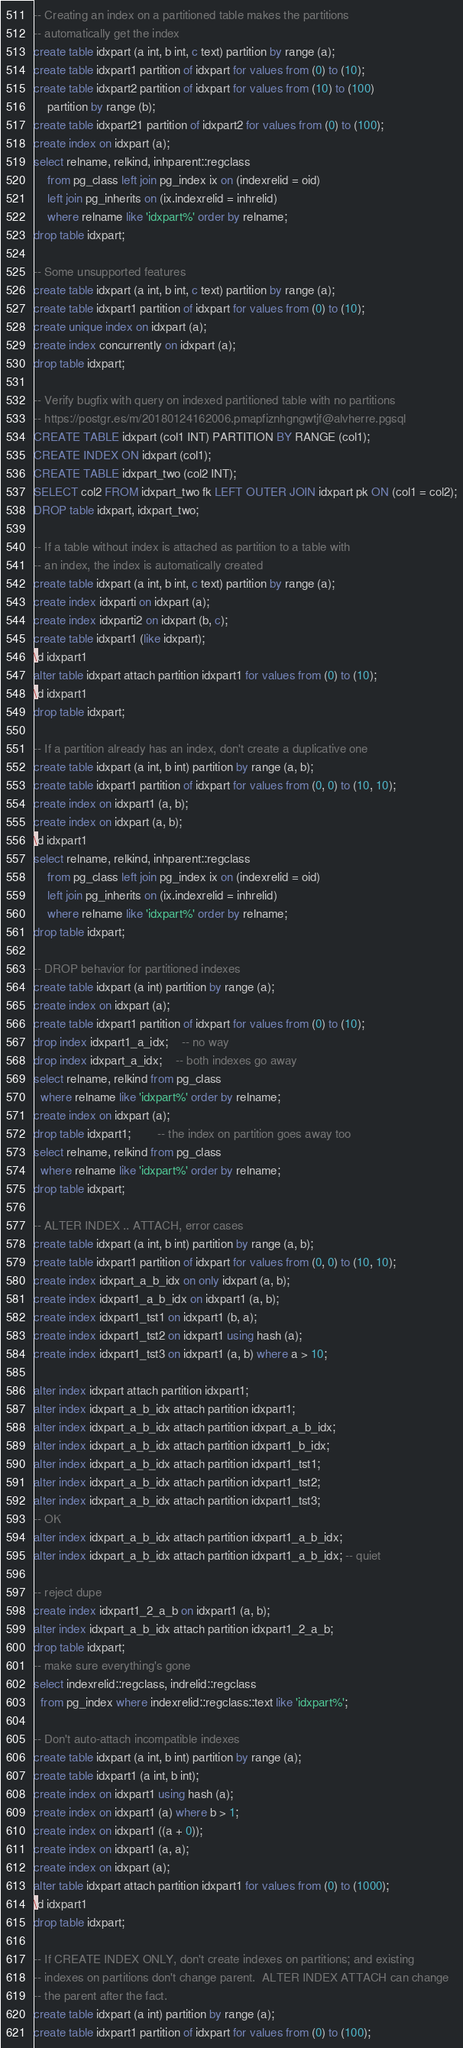Convert code to text. <code><loc_0><loc_0><loc_500><loc_500><_SQL_>-- Creating an index on a partitioned table makes the partitions
-- automatically get the index
create table idxpart (a int, b int, c text) partition by range (a);
create table idxpart1 partition of idxpart for values from (0) to (10);
create table idxpart2 partition of idxpart for values from (10) to (100)
	partition by range (b);
create table idxpart21 partition of idxpart2 for values from (0) to (100);
create index on idxpart (a);
select relname, relkind, inhparent::regclass
    from pg_class left join pg_index ix on (indexrelid = oid)
	left join pg_inherits on (ix.indexrelid = inhrelid)
	where relname like 'idxpart%' order by relname;
drop table idxpart;

-- Some unsupported features
create table idxpart (a int, b int, c text) partition by range (a);
create table idxpart1 partition of idxpart for values from (0) to (10);
create unique index on idxpart (a);
create index concurrently on idxpart (a);
drop table idxpart;

-- Verify bugfix with query on indexed partitioned table with no partitions
-- https://postgr.es/m/20180124162006.pmapfiznhgngwtjf@alvherre.pgsql
CREATE TABLE idxpart (col1 INT) PARTITION BY RANGE (col1);
CREATE INDEX ON idxpart (col1);
CREATE TABLE idxpart_two (col2 INT);
SELECT col2 FROM idxpart_two fk LEFT OUTER JOIN idxpart pk ON (col1 = col2);
DROP table idxpart, idxpart_two;

-- If a table without index is attached as partition to a table with
-- an index, the index is automatically created
create table idxpart (a int, b int, c text) partition by range (a);
create index idxparti on idxpart (a);
create index idxparti2 on idxpart (b, c);
create table idxpart1 (like idxpart);
\d idxpart1
alter table idxpart attach partition idxpart1 for values from (0) to (10);
\d idxpart1
drop table idxpart;

-- If a partition already has an index, don't create a duplicative one
create table idxpart (a int, b int) partition by range (a, b);
create table idxpart1 partition of idxpart for values from (0, 0) to (10, 10);
create index on idxpart1 (a, b);
create index on idxpart (a, b);
\d idxpart1
select relname, relkind, inhparent::regclass
    from pg_class left join pg_index ix on (indexrelid = oid)
	left join pg_inherits on (ix.indexrelid = inhrelid)
	where relname like 'idxpart%' order by relname;
drop table idxpart;

-- DROP behavior for partitioned indexes
create table idxpart (a int) partition by range (a);
create index on idxpart (a);
create table idxpart1 partition of idxpart for values from (0) to (10);
drop index idxpart1_a_idx;	-- no way
drop index idxpart_a_idx;	-- both indexes go away
select relname, relkind from pg_class
  where relname like 'idxpart%' order by relname;
create index on idxpart (a);
drop table idxpart1;		-- the index on partition goes away too
select relname, relkind from pg_class
  where relname like 'idxpart%' order by relname;
drop table idxpart;

-- ALTER INDEX .. ATTACH, error cases
create table idxpart (a int, b int) partition by range (a, b);
create table idxpart1 partition of idxpart for values from (0, 0) to (10, 10);
create index idxpart_a_b_idx on only idxpart (a, b);
create index idxpart1_a_b_idx on idxpart1 (a, b);
create index idxpart1_tst1 on idxpart1 (b, a);
create index idxpart1_tst2 on idxpart1 using hash (a);
create index idxpart1_tst3 on idxpart1 (a, b) where a > 10;

alter index idxpart attach partition idxpart1;
alter index idxpart_a_b_idx attach partition idxpart1;
alter index idxpart_a_b_idx attach partition idxpart_a_b_idx;
alter index idxpart_a_b_idx attach partition idxpart1_b_idx;
alter index idxpart_a_b_idx attach partition idxpart1_tst1;
alter index idxpart_a_b_idx attach partition idxpart1_tst2;
alter index idxpart_a_b_idx attach partition idxpart1_tst3;
-- OK
alter index idxpart_a_b_idx attach partition idxpart1_a_b_idx;
alter index idxpart_a_b_idx attach partition idxpart1_a_b_idx; -- quiet

-- reject dupe
create index idxpart1_2_a_b on idxpart1 (a, b);
alter index idxpart_a_b_idx attach partition idxpart1_2_a_b;
drop table idxpart;
-- make sure everything's gone
select indexrelid::regclass, indrelid::regclass
  from pg_index where indexrelid::regclass::text like 'idxpart%';

-- Don't auto-attach incompatible indexes
create table idxpart (a int, b int) partition by range (a);
create table idxpart1 (a int, b int);
create index on idxpart1 using hash (a);
create index on idxpart1 (a) where b > 1;
create index on idxpart1 ((a + 0));
create index on idxpart1 (a, a);
create index on idxpart (a);
alter table idxpart attach partition idxpart1 for values from (0) to (1000);
\d idxpart1
drop table idxpart;

-- If CREATE INDEX ONLY, don't create indexes on partitions; and existing
-- indexes on partitions don't change parent.  ALTER INDEX ATTACH can change
-- the parent after the fact.
create table idxpart (a int) partition by range (a);
create table idxpart1 partition of idxpart for values from (0) to (100);</code> 